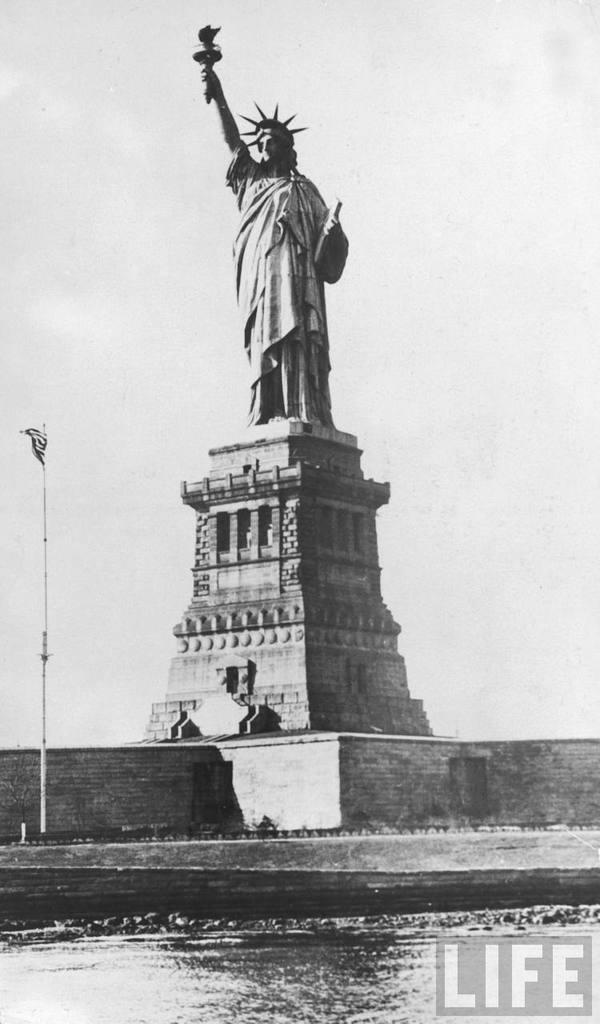Describe this image in one or two sentences. It is a black and white picture. In the center of the image we can see one stone. On the stone, we can see one liberty statue. At the bottom right side of the image, there is a watermark. In the background, we can see the sky and clouds. 